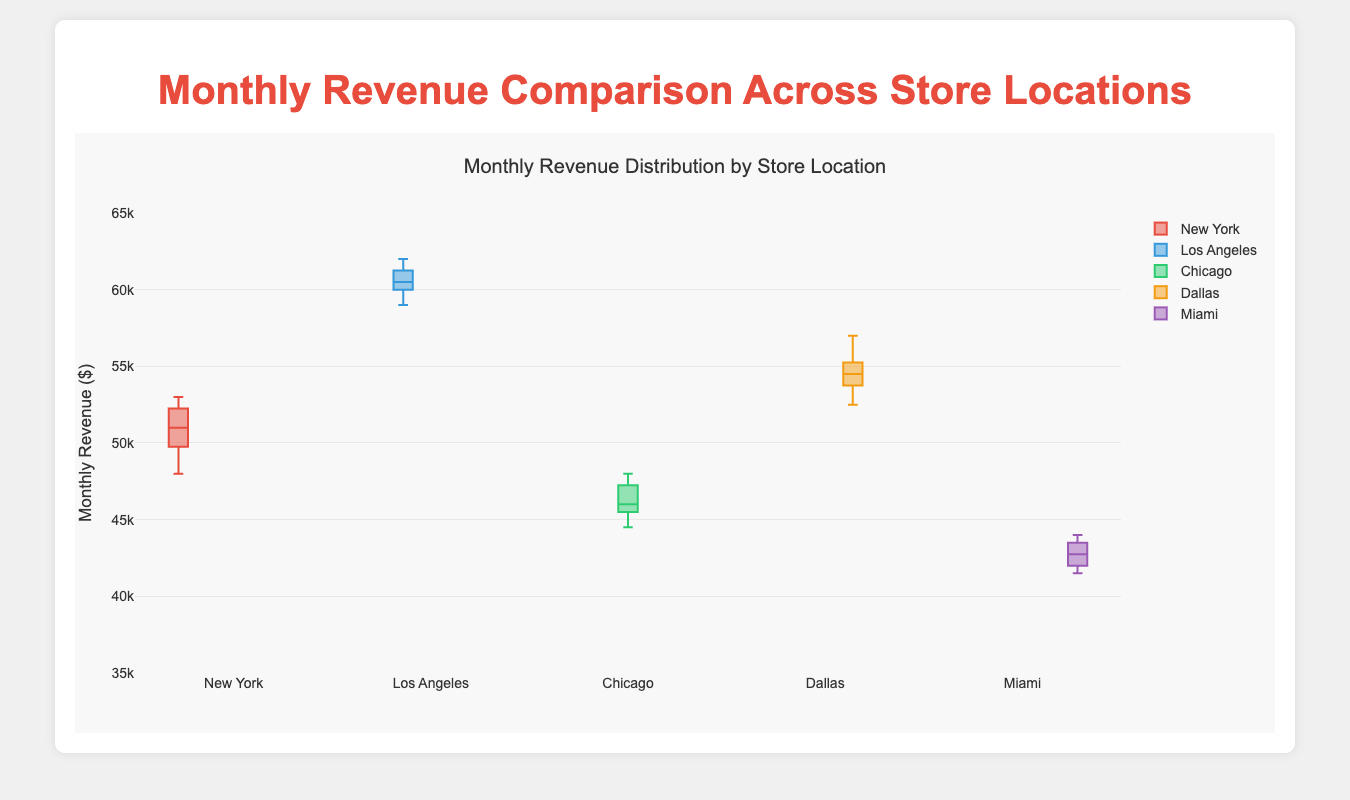What does the title of the figure indicate? The title of the figure provides information about what the plot represents, which is the comparison of monthly revenue across different store locations.
Answer: Monthly Revenue Distribution by Store Location Which city has the highest median monthly revenue? By looking at the median line inside each boxplot, you can see that Los Angeles has the highest median monthly revenue compared to other cities.
Answer: Los Angeles What is the approximate monthly revenue range for Dallas? The range in a box plot is indicated by the whiskers. For Dallas, the lower whisker is approximately $52500 and the upper whisker is around $57000.
Answer: $52500 - $57000 Which city has the lowest minimum monthly revenue? The minimum monthly revenue is represented by the lowest point of the whiskers for each box plot. Miami has the lowest minimum monthly revenue.
Answer: Miami What is the interquartile range (IQR) for New York's monthly revenue? The IQR is the range between the first quartile (Q1) and the third quartile (Q3). For New York, Q1 is around $49500 and Q3 is approximately $52000. So, IQR = $52000 - $49500.
Answer: $2500 Is there any location where the revenue data points are equally spaced around the median? For data to be equally spaced around the median, both the interquartile range (IQR) and the extension of the whiskers should be symmetric. New York displays a relatively symmetric spacing around the median.
Answer: New York Which city shows the least variability in monthly revenue? Variability is indicated by the length of the box (IQR) and the whiskers. Miami has the smallest box and whisker length, showing the least variability.
Answer: Miami Compare the median revenue of Chicago and Dallas. Which one is higher? The median is the line inside the box. Checking both cities, the median line for Dallas is higher than that for Chicago.
Answer: Dallas Which city shows the highest maximum monthly revenue according to the plot? The maximum revenue is represented by the highest point of the whiskers, and for Los Angeles, it is the highest among the cities in the plot.
Answer: Los Angeles How do the median monthly revenues of New York and Miami compare? By comparing the median lines inside the boxes, you can see that New York’s median monthly revenue is higher than Miami’s.
Answer: New York 